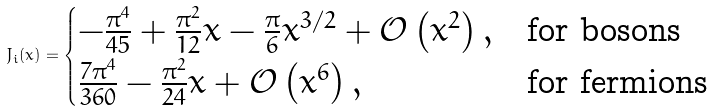Convert formula to latex. <formula><loc_0><loc_0><loc_500><loc_500>J _ { i } ( x ) = \begin{cases} - \frac { \pi ^ { 4 } } { 4 5 } + \frac { \pi ^ { 2 } } { 1 2 } x - \frac { \pi } { 6 } x ^ { 3 / 2 } + \mathcal { O } \left ( x ^ { 2 } \right ) , & \text {for bosons} \\ \frac { 7 \pi ^ { 4 } } { 3 6 0 } - \frac { \pi ^ { 2 } } { 2 4 } x + \mathcal { O } \left ( x ^ { 6 } \right ) , & \text {for fermions} \end{cases}</formula> 